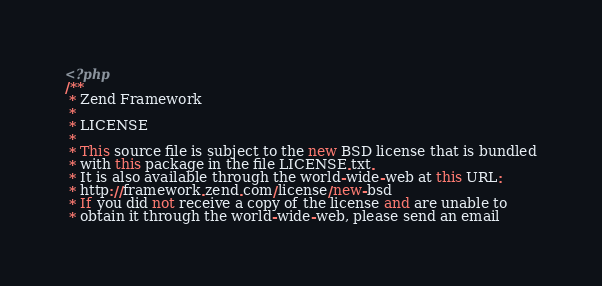Convert code to text. <code><loc_0><loc_0><loc_500><loc_500><_PHP_><?php
/**
 * Zend Framework
 *
 * LICENSE
 *
 * This source file is subject to the new BSD license that is bundled
 * with this package in the file LICENSE.txt.
 * It is also available through the world-wide-web at this URL:
 * http://framework.zend.com/license/new-bsd
 * If you did not receive a copy of the license and are unable to
 * obtain it through the world-wide-web, please send an email</code> 